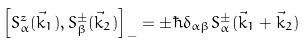Convert formula to latex. <formula><loc_0><loc_0><loc_500><loc_500>\left [ S _ { \alpha } ^ { z } ( \vec { k } _ { 1 } ) , S _ { \beta } ^ { \pm } ( \vec { k } _ { 2 } ) \right ] _ { - } = \pm \hbar { \delta } _ { \alpha \beta } S _ { \alpha } ^ { \pm } ( \vec { k } _ { 1 } + \vec { k } _ { 2 } )</formula> 